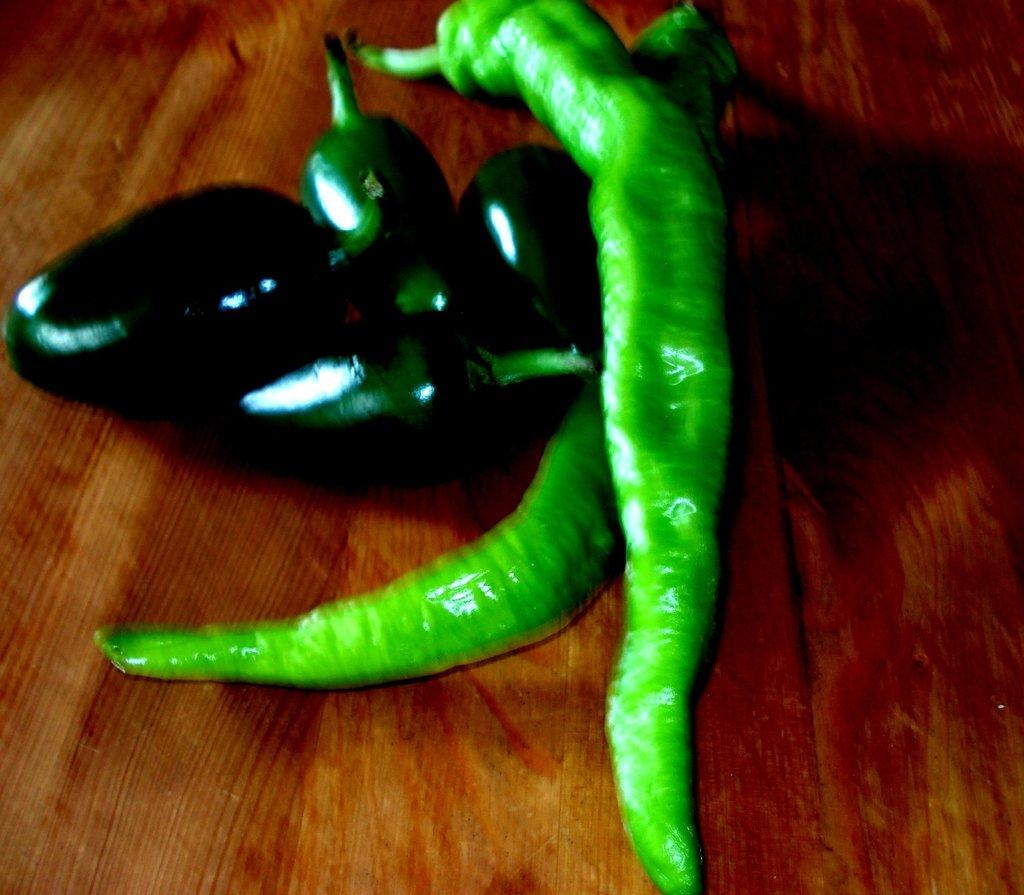What type of vegetables are present in the image? There are chilies and eggplants in the image. How are the chilies and eggplants arranged in the image? The chilies and eggplants are placed on top of an object. How many girls are climbing the tree in the image? There is no tree or girls present in the image; it features chilies and eggplants placed on top of an object. 